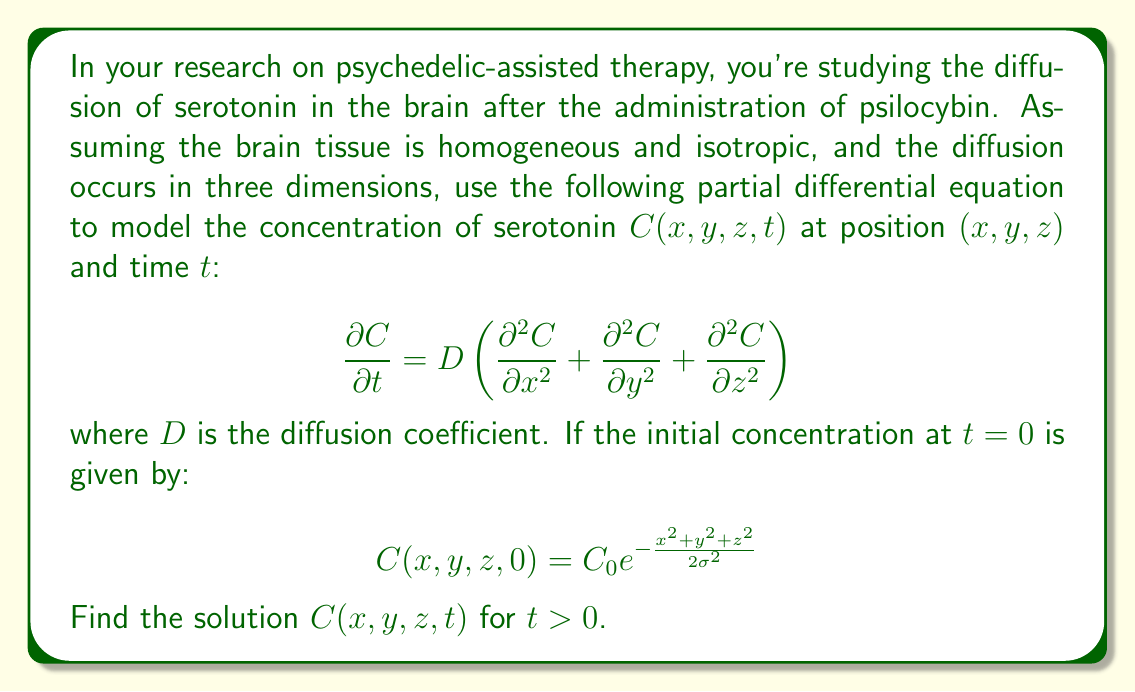Can you solve this math problem? To solve this partial differential equation (PDE), we'll follow these steps:

1) Recognize that this is the 3D diffusion equation (also known as the heat equation).

2) The initial condition is a 3D Gaussian distribution.

3) For such PDEs with Gaussian initial conditions, we can use the method of separation of variables and Fourier transforms.

4) The solution will have the form of a Gaussian distribution that spreads out over time.

5) The general solution for a 3D diffusion equation with a Gaussian initial condition is:

   $$C(x,y,z,t) = \frac{C_0\sigma^3}{(\sigma^2 + 2Dt)^{3/2}} \exp\left(-\frac{x^2+y^2+z^2}{2(\sigma^2 + 2Dt)}\right)$$

6) We can verify this solution by:
   a) Checking that it satisfies the PDE
   b) Confirming that it matches the initial condition at $t=0$

7) To check that it satisfies the PDE, we calculate the partial derivatives:

   $$\frac{\partial C}{\partial t} = C_0\sigma^3 \left[-\frac{3D}{(\sigma^2 + 2Dt)^{5/2}} + \frac{D(x^2+y^2+z^2)}{(\sigma^2 + 2Dt)^{7/2}}\right] \exp\left(-\frac{x^2+y^2+z^2}{2(\sigma^2 + 2Dt)}\right)$$

   $$\frac{\partial^2 C}{\partial x^2} = C_0\sigma^3 \left[\frac{x^2}{(\sigma^2 + 2Dt)^{7/2}} - \frac{1}{(\sigma^2 + 2Dt)^{5/2}}\right] \exp\left(-\frac{x^2+y^2+z^2}{2(\sigma^2 + 2Dt)}\right)$$

   Similar expressions hold for $\frac{\partial^2 C}{\partial y^2}$ and $\frac{\partial^2 C}{\partial z^2}$.

8) Substituting these into the PDE, we can verify that the equation is satisfied.

9) To check the initial condition, we set $t=0$ in our solution:

   $$C(x,y,z,0) = \frac{C_0\sigma^3}{(\sigma^2)^{3/2}} \exp\left(-\frac{x^2+y^2+z^2}{2\sigma^2}\right) = C_0 \exp\left(-\frac{x^2+y^2+z^2}{2\sigma^2}\right)$$

   This matches the given initial condition.

Therefore, the solution satisfies both the PDE and the initial condition, confirming its validity.
Answer: $$C(x,y,z,t) = \frac{C_0\sigma^3}{(\sigma^2 + 2Dt)^{3/2}} \exp\left(-\frac{x^2+y^2+z^2}{2(\sigma^2 + 2Dt)}\right)$$ 